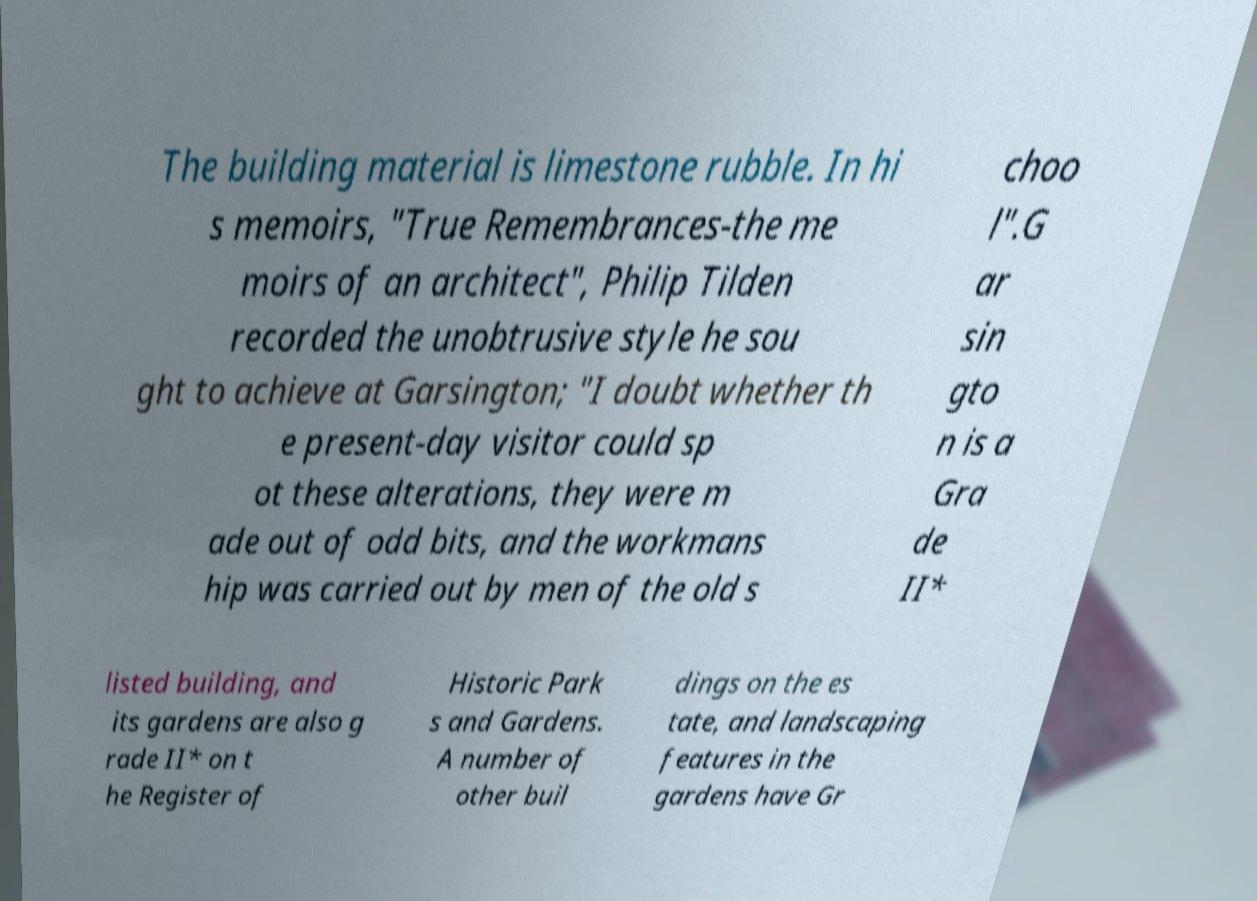Can you read and provide the text displayed in the image?This photo seems to have some interesting text. Can you extract and type it out for me? The building material is limestone rubble. In hi s memoirs, "True Remembrances-the me moirs of an architect", Philip Tilden recorded the unobtrusive style he sou ght to achieve at Garsington; "I doubt whether th e present-day visitor could sp ot these alterations, they were m ade out of odd bits, and the workmans hip was carried out by men of the old s choo l".G ar sin gto n is a Gra de II* listed building, and its gardens are also g rade II* on t he Register of Historic Park s and Gardens. A number of other buil dings on the es tate, and landscaping features in the gardens have Gr 